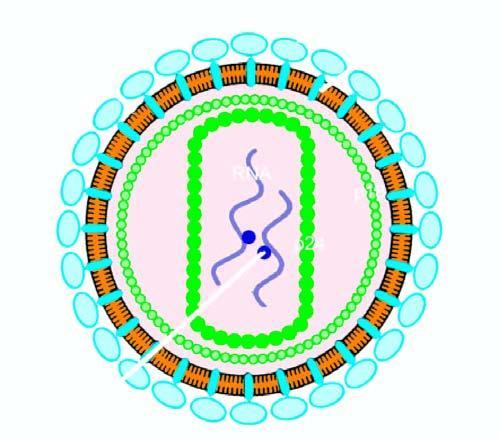does the particle have core containing proteins, p24 and p18, two strands of viral rna, and enzyme reverse transcriptase?
Answer the question using a single word or phrase. Yes 